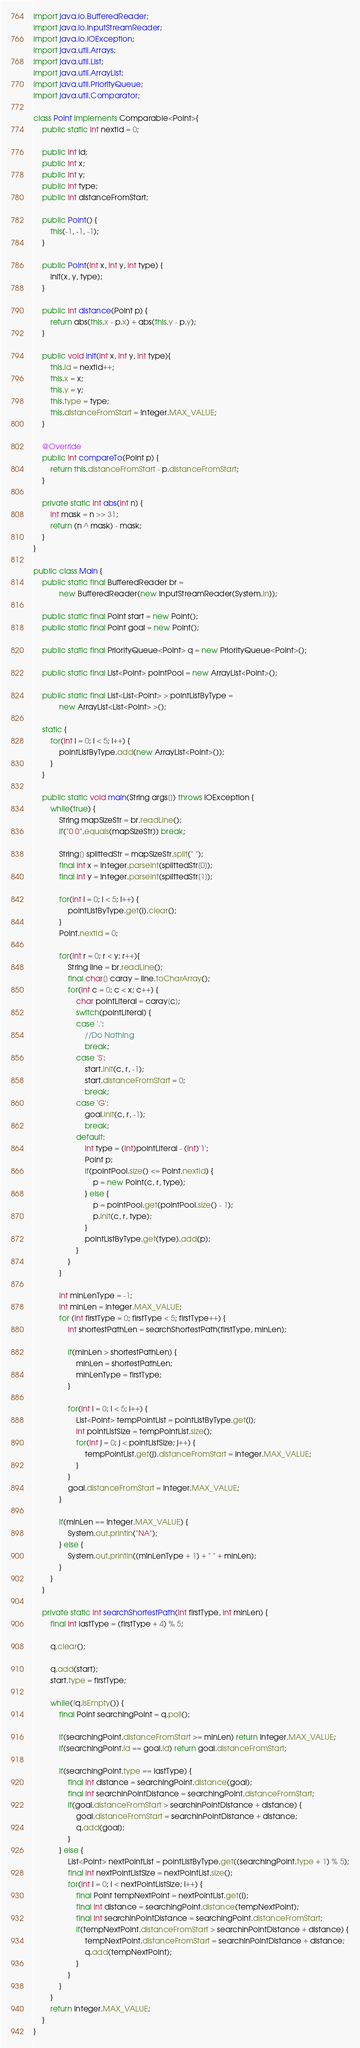Convert code to text. <code><loc_0><loc_0><loc_500><loc_500><_Java_>import java.io.BufferedReader;
import java.io.InputStreamReader;
import java.io.IOException;
import java.util.Arrays;
import java.util.List;
import java.util.ArrayList;
import java.util.PriorityQueue;
import java.util.Comparator;
 
class Point implements Comparable<Point>{
    public static int nextId = 0;
  
    public int id;
    public int x;
    public int y;
    public int type;
    public int distanceFromStart;
    
    public Point() {
        this(-1, -1, -1);
    }
     
    public Point(int x, int y, int type) {
        init(x, y, type);
    }
  
    public int distance(Point p) {
        return abs(this.x - p.x) + abs(this.y - p.y);
    }
     
    public void init(int x, int y, int type){
        this.id = nextId++;
        this.x = x;
        this.y = y;
        this.type = type;
        this.distanceFromStart = Integer.MAX_VALUE;
    }
    
    @Override
    public int compareTo(Point p) {
        return this.distanceFromStart - p.distanceFromStart;
    }
     
    private static int abs(int n) {
        int mask = n >> 31;
        return (n ^ mask) - mask;
    }
}
  
public class Main {
    public static final BufferedReader br =
            new BufferedReader(new InputStreamReader(System.in));
  
    public static final Point start = new Point();
    public static final Point goal = new Point();

    public static final PriorityQueue<Point> q = new PriorityQueue<Point>();
 
    public static final List<Point> pointPool = new ArrayList<Point>();
     
    public static final List<List<Point> > pointListByType =
            new ArrayList<List<Point> >();
     
    static {
        for(int i = 0; i < 5; i++) {
            pointListByType.add(new ArrayList<Point>());
        }
    }
  
    public static void main(String args[]) throws IOException {
        while(true) {
            String mapSizeStr = br.readLine();
            if("0 0".equals(mapSizeStr)) break;
  
            String[] splittedStr = mapSizeStr.split(" ");
            final int x = Integer.parseInt(splittedStr[0]);
            final int y = Integer.parseInt(splittedStr[1]);
                 
            for(int i = 0; i < 5; i++) {
                pointListByType.get(i).clear();
            }
            Point.nextId = 0;
  
            for(int r = 0; r < y; r++){
                String line = br.readLine();
                final char[] caray = line.toCharArray();
                for(int c = 0; c < x; c++) {
                    char pointLiteral = caray[c];
                    switch(pointLiteral) {
                    case '.':
                        //Do Nothing
                        break;
                    case 'S':
                        start.init(c, r, -1);
                        start.distanceFromStart = 0;
                        break;
                    case 'G':
                        goal.init(c, r, -1);
                        break;
                    default:
                        int type = (int)pointLiteral - (int)'1';
                        Point p;
                        if(pointPool.size() <= Point.nextId) {
                            p = new Point(c, r, type);
                        } else {
                            p = pointPool.get(pointPool.size() - 1);
                            p.init(c, r, type);
                        }
                        pointListByType.get(type).add(p);
                    }
                }
            }
  
            int minLenType = -1;
            int minLen = Integer.MAX_VALUE;
            for (int firstType = 0; firstType < 5; firstType++) { 
                int shortestPathLen = searchShortestPath(firstType, minLen);
  
                if(minLen > shortestPathLen) {
                    minLen = shortestPathLen;
                    minLenType = firstType;
                }
  
                for(int i = 0; i < 5; i++) {
                    List<Point> tempPointList = pointListByType.get(i);
                    int pointListSize = tempPointList.size();
                    for(int j = 0; j < pointListSize; j++) {
                        tempPointList.get(j).distanceFromStart = Integer.MAX_VALUE;
                    }
                }
                goal.distanceFromStart = Integer.MAX_VALUE;
            }
  
            if(minLen == Integer.MAX_VALUE) {
                System.out.println("NA");
            } else {
                System.out.println((minLenType + 1) + " " + minLen);
            }
        }
    }
  
    private static int searchShortestPath(int firstType, int minLen) {
        final int lastType = (firstType + 4) % 5;
            
        q.clear();
  
        q.add(start);
        start.type = firstType;
           
        while(!q.isEmpty()) {
            final Point searchingPoint = q.poll();

            if(searchingPoint.distanceFromStart >= minLen) return Integer.MAX_VALUE;
            if(searchingPoint.id == goal.id) return goal.distanceFromStart;

            if(searchingPoint.type == lastType) {
                final int distance = searchingPoint.distance(goal);
                final int searchinPointDistance = searchingPoint.distanceFromStart;
                if(goal.distanceFromStart > searchinPointDistance + distance) {
                    goal.distanceFromStart = searchinPointDistance + distance;
                    q.add(goal);
                }
            } else {
                List<Point> nextPointList = pointListByType.get((searchingPoint.type + 1) % 5);
                final int nextPointListSize = nextPointList.size();
                for(int i = 0; i < nextPointListSize; i++) {
                    final Point tempNextPoint = nextPointList.get(i);
                    final int distance = searchingPoint.distance(tempNextPoint);
                    final int searchinPointDistance = searchingPoint.distanceFromStart;
                    if(tempNextPoint.distanceFromStart > searchinPointDistance + distance) {
                        tempNextPoint.distanceFromStart = searchinPointDistance + distance;
                        q.add(tempNextPoint);
                    }
                }
            }
        }
        return Integer.MAX_VALUE;
    }
}   </code> 